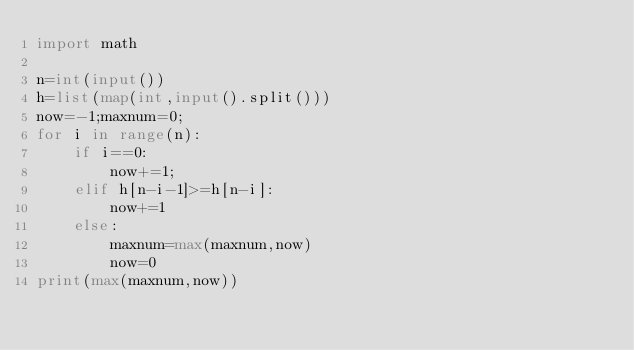<code> <loc_0><loc_0><loc_500><loc_500><_Python_>import math

n=int(input())
h=list(map(int,input().split()))
now=-1;maxnum=0;
for i in range(n):
    if i==0:
        now+=1;
    elif h[n-i-1]>=h[n-i]:
        now+=1
    else:
        maxnum=max(maxnum,now)
        now=0
print(max(maxnum,now))
</code> 